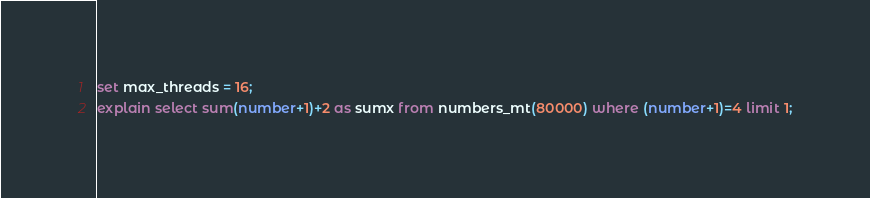<code> <loc_0><loc_0><loc_500><loc_500><_SQL_>set max_threads = 16;
explain select sum(number+1)+2 as sumx from numbers_mt(80000) where (number+1)=4 limit 1;
</code> 